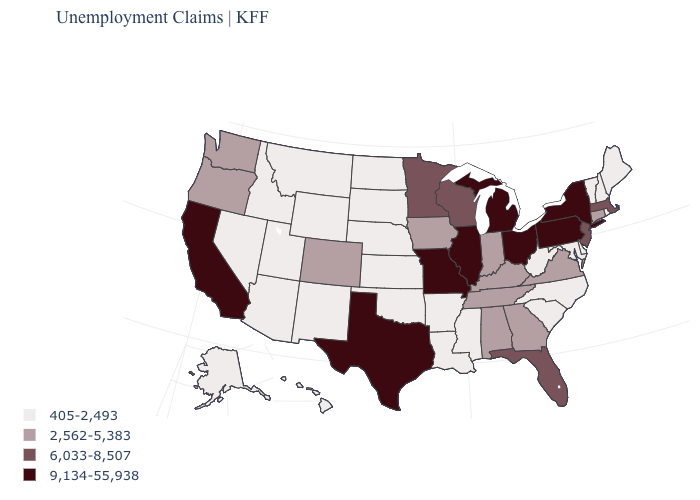Name the states that have a value in the range 2,562-5,383?
Write a very short answer. Alabama, Colorado, Connecticut, Georgia, Indiana, Iowa, Kentucky, Oregon, Tennessee, Virginia, Washington. What is the value of Delaware?
Give a very brief answer. 405-2,493. Which states have the lowest value in the Northeast?
Quick response, please. Maine, New Hampshire, Rhode Island, Vermont. What is the value of Pennsylvania?
Keep it brief. 9,134-55,938. Name the states that have a value in the range 405-2,493?
Quick response, please. Alaska, Arizona, Arkansas, Delaware, Hawaii, Idaho, Kansas, Louisiana, Maine, Maryland, Mississippi, Montana, Nebraska, Nevada, New Hampshire, New Mexico, North Carolina, North Dakota, Oklahoma, Rhode Island, South Carolina, South Dakota, Utah, Vermont, West Virginia, Wyoming. Is the legend a continuous bar?
Quick response, please. No. What is the value of Iowa?
Write a very short answer. 2,562-5,383. Does South Dakota have the highest value in the MidWest?
Answer briefly. No. What is the lowest value in the USA?
Be succinct. 405-2,493. Is the legend a continuous bar?
Answer briefly. No. Which states have the lowest value in the USA?
Answer briefly. Alaska, Arizona, Arkansas, Delaware, Hawaii, Idaho, Kansas, Louisiana, Maine, Maryland, Mississippi, Montana, Nebraska, Nevada, New Hampshire, New Mexico, North Carolina, North Dakota, Oklahoma, Rhode Island, South Carolina, South Dakota, Utah, Vermont, West Virginia, Wyoming. What is the highest value in states that border Nebraska?
Give a very brief answer. 9,134-55,938. What is the highest value in the USA?
Keep it brief. 9,134-55,938. Among the states that border Maryland , does Pennsylvania have the highest value?
Be succinct. Yes. What is the lowest value in the USA?
Be succinct. 405-2,493. 